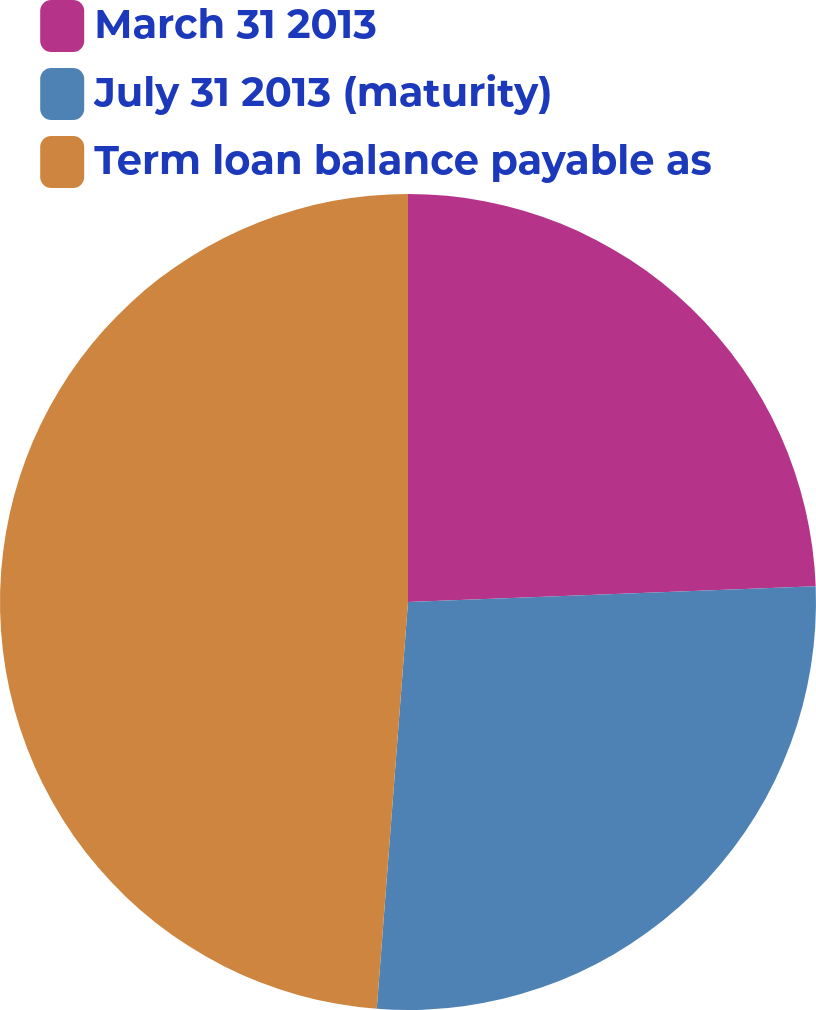Convert chart to OTSL. <chart><loc_0><loc_0><loc_500><loc_500><pie_chart><fcel>March 31 2013<fcel>July 31 2013 (maturity)<fcel>Term loan balance payable as<nl><fcel>24.39%<fcel>26.83%<fcel>48.78%<nl></chart> 